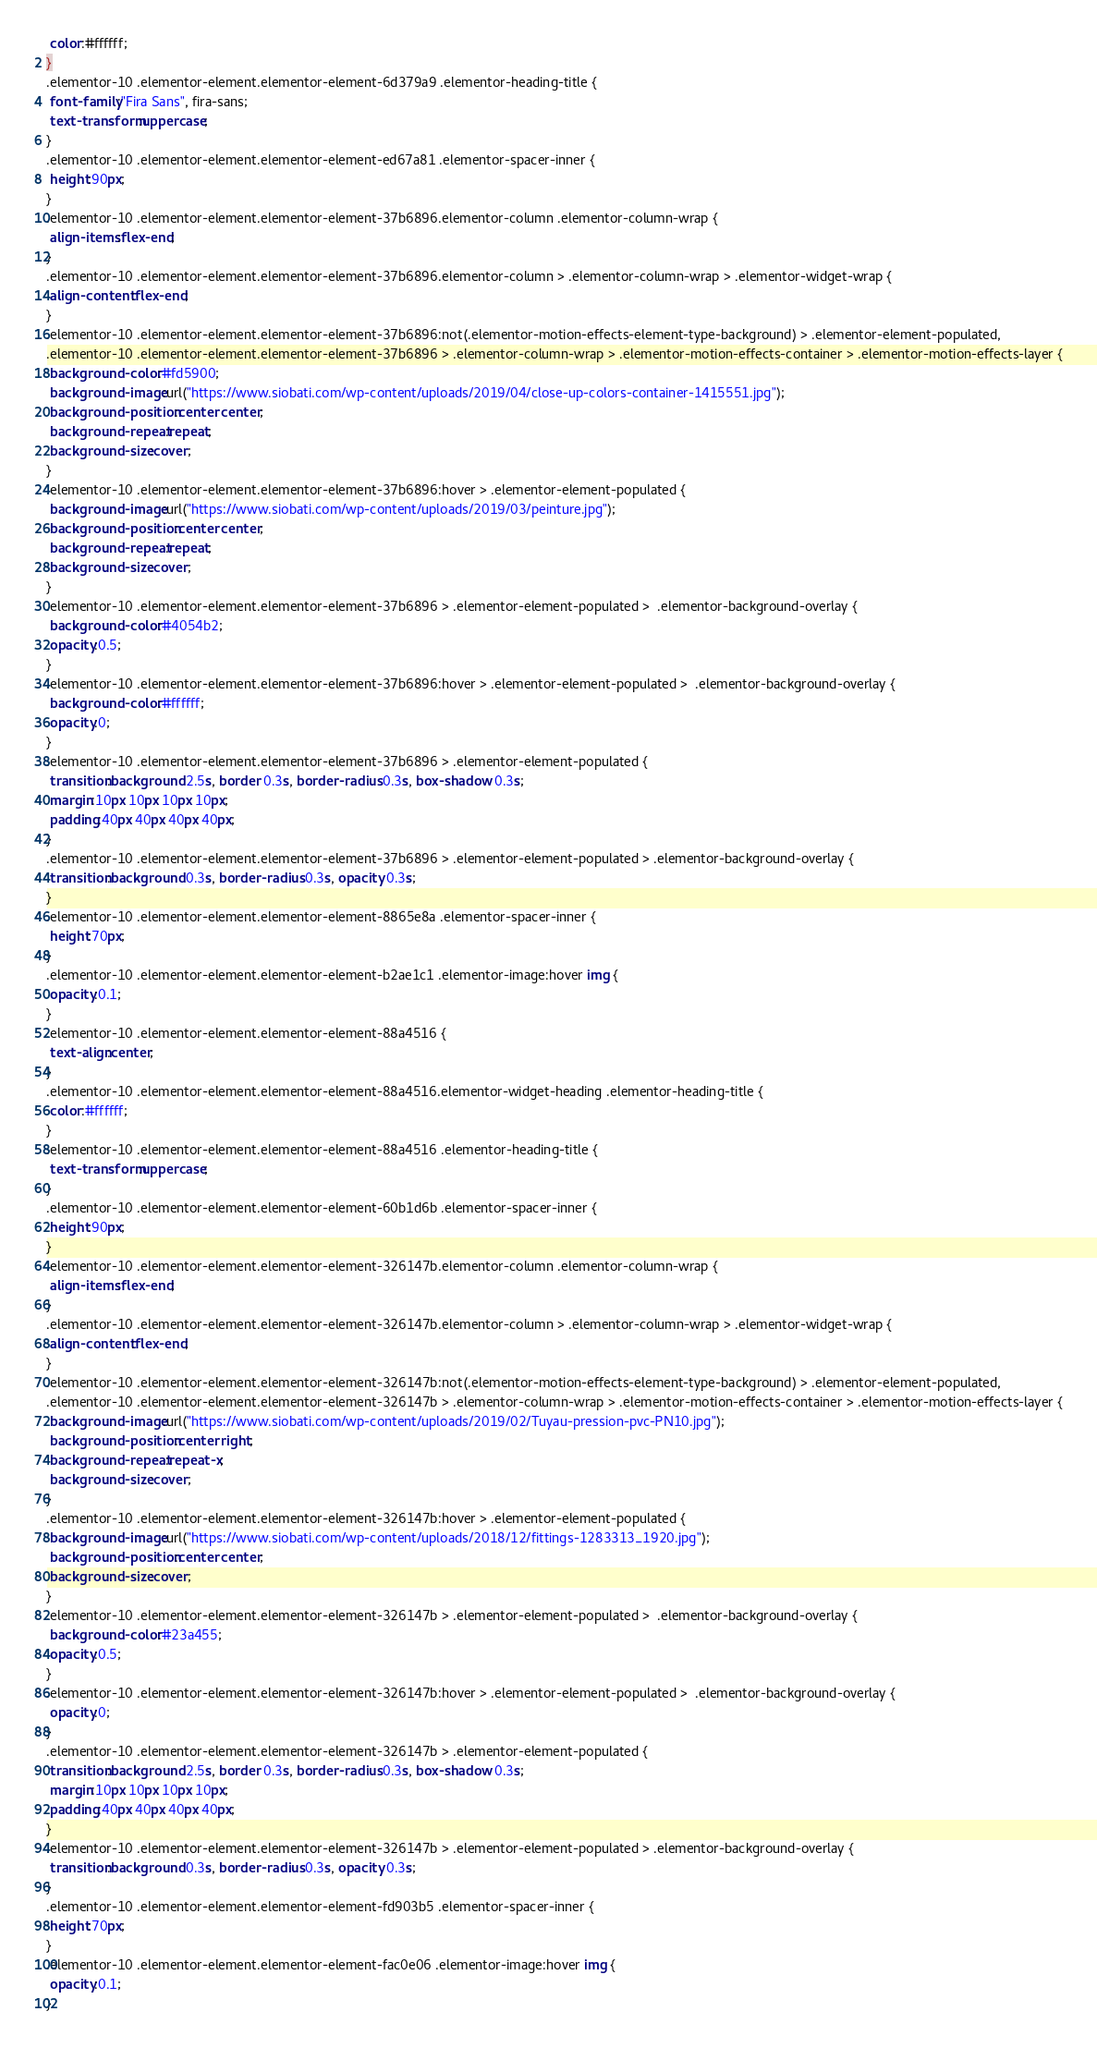Convert code to text. <code><loc_0><loc_0><loc_500><loc_500><_CSS_> color:#ffffff;
}
.elementor-10 .elementor-element.elementor-element-6d379a9 .elementor-heading-title {
 font-family:"Fira Sans", fira-sans;
 text-transform:uppercase;
}
.elementor-10 .elementor-element.elementor-element-ed67a81 .elementor-spacer-inner {
 height:90px;
}
.elementor-10 .elementor-element.elementor-element-37b6896.elementor-column .elementor-column-wrap {
 align-items:flex-end;
}
.elementor-10 .elementor-element.elementor-element-37b6896.elementor-column > .elementor-column-wrap > .elementor-widget-wrap {
 align-content:flex-end;
}
.elementor-10 .elementor-element.elementor-element-37b6896:not(.elementor-motion-effects-element-type-background) > .elementor-element-populated,
.elementor-10 .elementor-element.elementor-element-37b6896 > .elementor-column-wrap > .elementor-motion-effects-container > .elementor-motion-effects-layer {
 background-color:#fd5900;
 background-image:url("https://www.siobati.com/wp-content/uploads/2019/04/close-up-colors-container-1415551.jpg");
 background-position:center center;
 background-repeat:repeat;
 background-size:cover;
}
.elementor-10 .elementor-element.elementor-element-37b6896:hover > .elementor-element-populated {
 background-image:url("https://www.siobati.com/wp-content/uploads/2019/03/peinture.jpg");
 background-position:center center;
 background-repeat:repeat;
 background-size:cover;
}
.elementor-10 .elementor-element.elementor-element-37b6896 > .elementor-element-populated >  .elementor-background-overlay {
 background-color:#4054b2;
 opacity:0.5;
}
.elementor-10 .elementor-element.elementor-element-37b6896:hover > .elementor-element-populated >  .elementor-background-overlay {
 background-color:#ffffff;
 opacity:0;
}
.elementor-10 .elementor-element.elementor-element-37b6896 > .elementor-element-populated {
 transition:background 2.5s, border 0.3s, border-radius 0.3s, box-shadow 0.3s;
 margin:10px 10px 10px 10px;
 padding:40px 40px 40px 40px;
}
.elementor-10 .elementor-element.elementor-element-37b6896 > .elementor-element-populated > .elementor-background-overlay {
 transition:background 0.3s, border-radius 0.3s, opacity 0.3s;
}
.elementor-10 .elementor-element.elementor-element-8865e8a .elementor-spacer-inner {
 height:70px;
}
.elementor-10 .elementor-element.elementor-element-b2ae1c1 .elementor-image:hover img {
 opacity:0.1;
}
.elementor-10 .elementor-element.elementor-element-88a4516 {
 text-align:center;
}
.elementor-10 .elementor-element.elementor-element-88a4516.elementor-widget-heading .elementor-heading-title {
 color:#ffffff;
}
.elementor-10 .elementor-element.elementor-element-88a4516 .elementor-heading-title {
 text-transform:uppercase;
}
.elementor-10 .elementor-element.elementor-element-60b1d6b .elementor-spacer-inner {
 height:90px;
}
.elementor-10 .elementor-element.elementor-element-326147b.elementor-column .elementor-column-wrap {
 align-items:flex-end;
}
.elementor-10 .elementor-element.elementor-element-326147b.elementor-column > .elementor-column-wrap > .elementor-widget-wrap {
 align-content:flex-end;
}
.elementor-10 .elementor-element.elementor-element-326147b:not(.elementor-motion-effects-element-type-background) > .elementor-element-populated,
.elementor-10 .elementor-element.elementor-element-326147b > .elementor-column-wrap > .elementor-motion-effects-container > .elementor-motion-effects-layer {
 background-image:url("https://www.siobati.com/wp-content/uploads/2019/02/Tuyau-pression-pvc-PN10.jpg");
 background-position:center right;
 background-repeat:repeat-x;
 background-size:cover;
}
.elementor-10 .elementor-element.elementor-element-326147b:hover > .elementor-element-populated {
 background-image:url("https://www.siobati.com/wp-content/uploads/2018/12/fittings-1283313_1920.jpg");
 background-position:center center;
 background-size:cover;
}
.elementor-10 .elementor-element.elementor-element-326147b > .elementor-element-populated >  .elementor-background-overlay {
 background-color:#23a455;
 opacity:0.5;
}
.elementor-10 .elementor-element.elementor-element-326147b:hover > .elementor-element-populated >  .elementor-background-overlay {
 opacity:0;
}
.elementor-10 .elementor-element.elementor-element-326147b > .elementor-element-populated {
 transition:background 2.5s, border 0.3s, border-radius 0.3s, box-shadow 0.3s;
 margin:10px 10px 10px 10px;
 padding:40px 40px 40px 40px;
}
.elementor-10 .elementor-element.elementor-element-326147b > .elementor-element-populated > .elementor-background-overlay {
 transition:background 0.3s, border-radius 0.3s, opacity 0.3s;
}
.elementor-10 .elementor-element.elementor-element-fd903b5 .elementor-spacer-inner {
 height:70px;
}
.elementor-10 .elementor-element.elementor-element-fac0e06 .elementor-image:hover img {
 opacity:0.1;
}</code> 